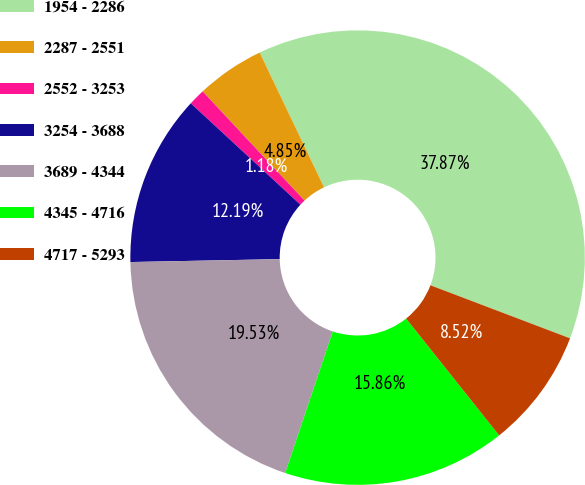<chart> <loc_0><loc_0><loc_500><loc_500><pie_chart><fcel>1954 - 2286<fcel>2287 - 2551<fcel>2552 - 3253<fcel>3254 - 3688<fcel>3689 - 4344<fcel>4345 - 4716<fcel>4717 - 5293<nl><fcel>37.87%<fcel>4.85%<fcel>1.18%<fcel>12.19%<fcel>19.53%<fcel>15.86%<fcel>8.52%<nl></chart> 